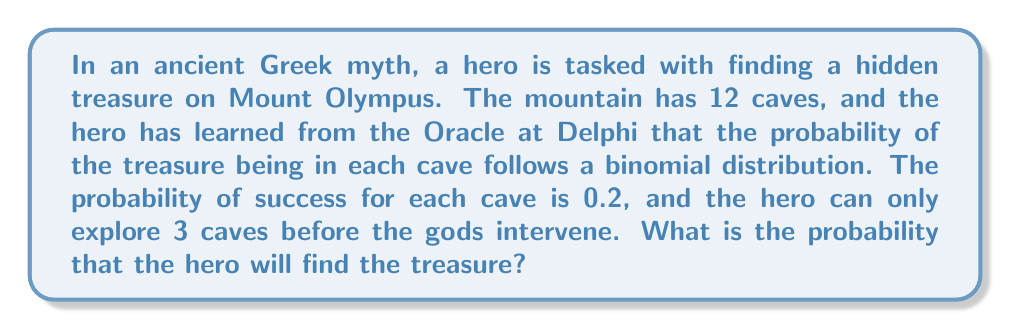Show me your answer to this math problem. To solve this problem, we need to use the binomial probability distribution. The binomial distribution is used when we have a fixed number of independent trials, each with the same probability of success.

In this case:
- Number of trials (caves explored): $n = 3$
- Probability of success for each cave: $p = 0.2$
- We want to find the probability of at least one success (finding the treasure)

The probability of finding the treasure is the opposite of not finding the treasure in any of the three caves explored.

1. First, let's calculate the probability of not finding the treasure in a single cave:
   $P(\text{no treasure}) = 1 - p = 1 - 0.2 = 0.8$

2. The probability of not finding the treasure in all three caves is:
   $P(\text{no treasure in 3 caves}) = 0.8^3 = 0.512$

3. Therefore, the probability of finding the treasure in at least one of the three caves is:
   $P(\text{finding treasure}) = 1 - P(\text{no treasure in 3 caves})$
   $= 1 - 0.512 = 0.488$

We can also calculate this using the binomial probability formula:

$$P(X \geq 1) = 1 - P(X = 0) = 1 - \binom{3}{0}(0.2)^0(0.8)^3 = 1 - 0.512 = 0.488$$

Where $\binom{3}{0}$ is the binomial coefficient, calculated as:

$$\binom{3}{0} = \frac{3!}{0!(3-0)!} = 1$$
Answer: The probability that the hero will find the treasure is 0.488 or 48.8%. 